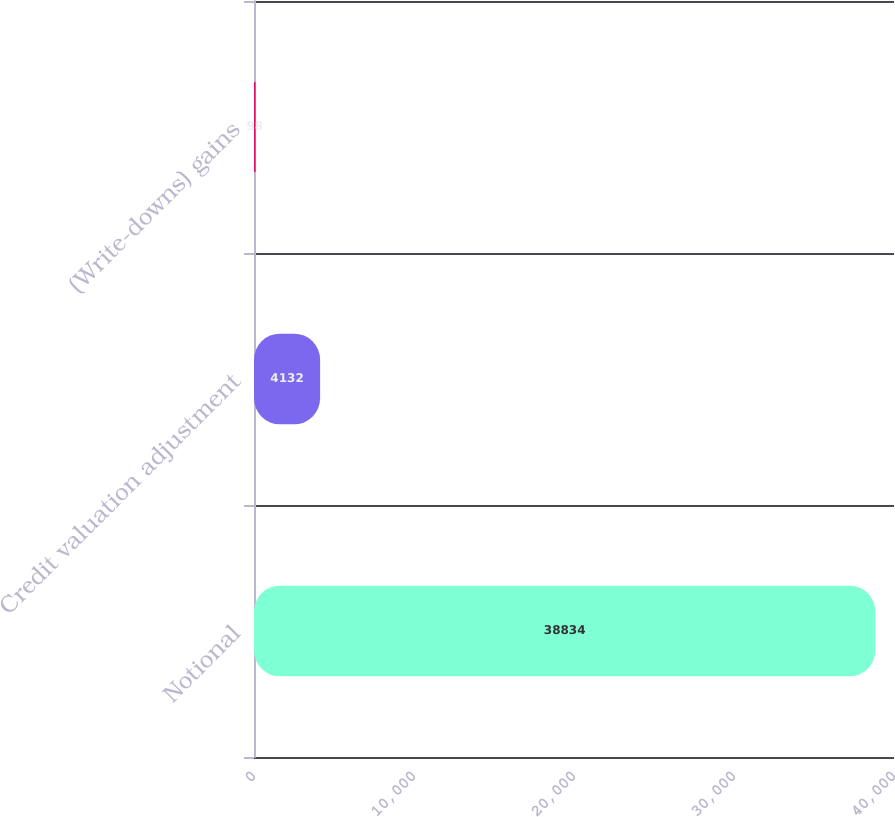Convert chart. <chart><loc_0><loc_0><loc_500><loc_500><bar_chart><fcel>Notional<fcel>Credit valuation adjustment<fcel>(Write-downs) gains<nl><fcel>38834<fcel>4132<fcel>98<nl></chart> 